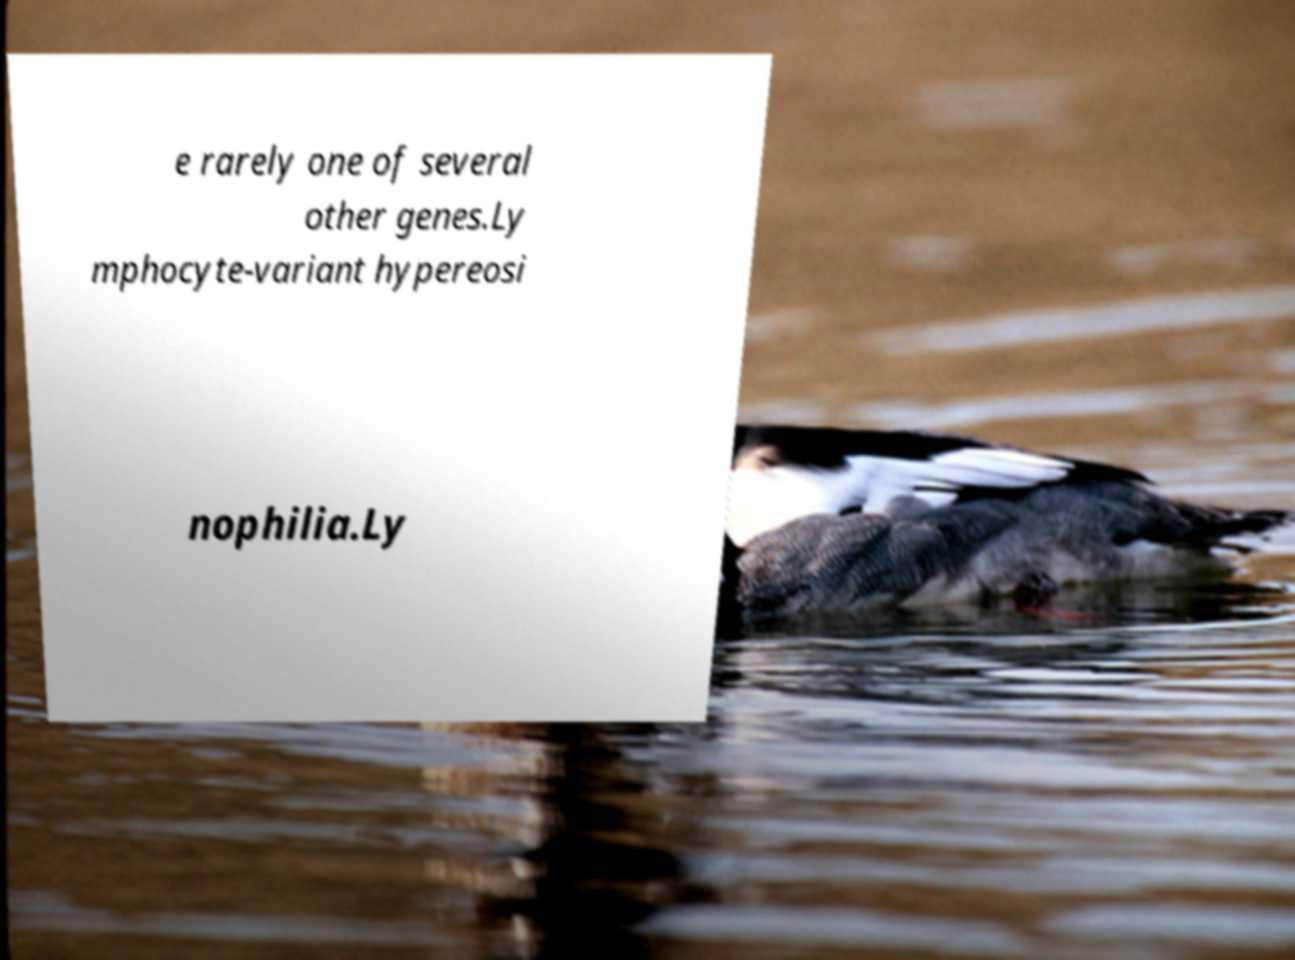Please identify and transcribe the text found in this image. e rarely one of several other genes.Ly mphocyte-variant hypereosi nophilia.Ly 